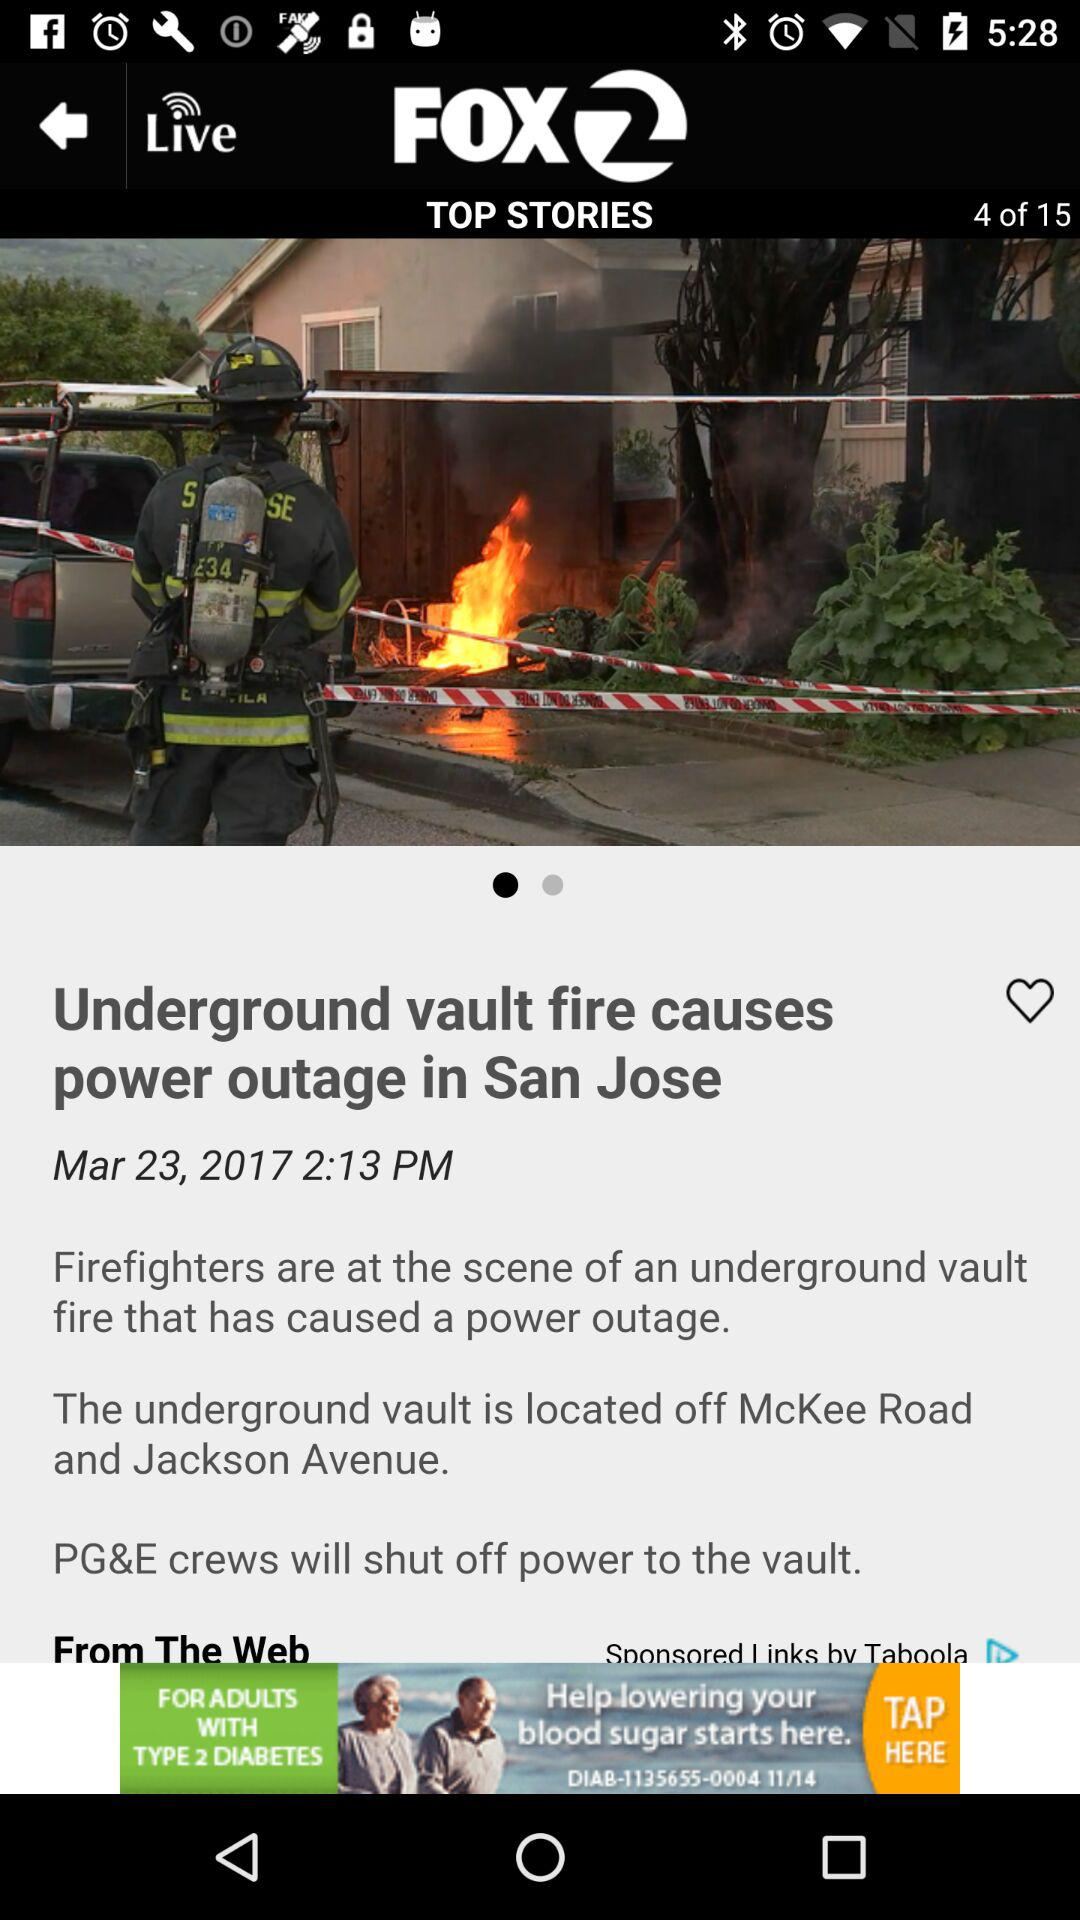How many total top stories are there? There are a total of 15 top stories. 